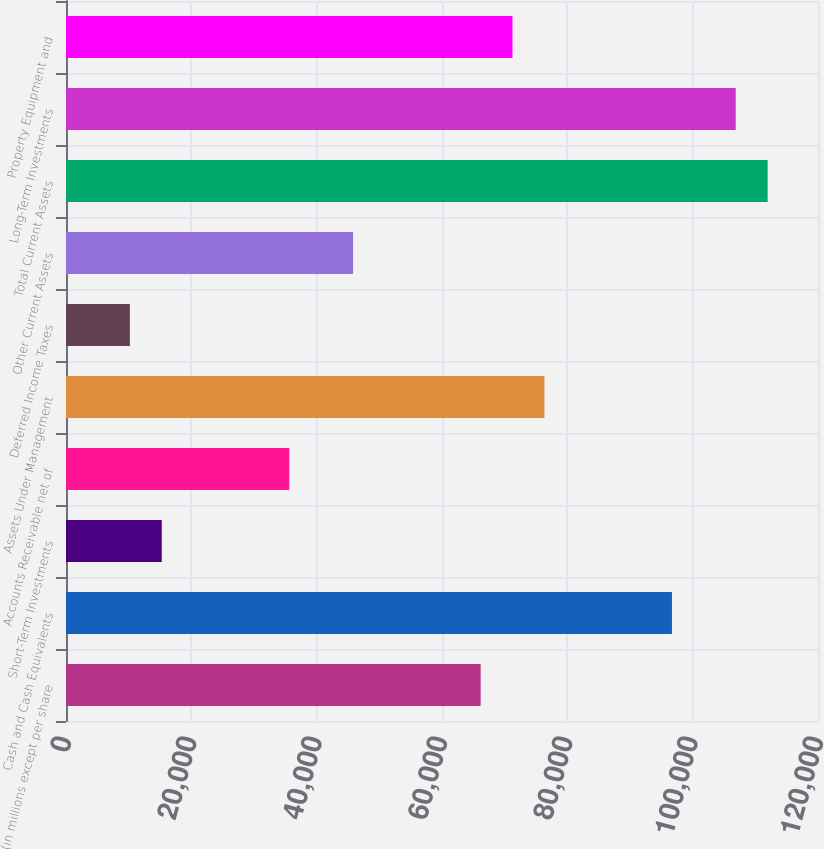<chart> <loc_0><loc_0><loc_500><loc_500><bar_chart><fcel>(in millions except per share<fcel>Cash and Cash Equivalents<fcel>Short-Term Investments<fcel>Accounts Receivable net of<fcel>Assets Under Management<fcel>Deferred Income Taxes<fcel>Other Current Assets<fcel>Total Current Assets<fcel>Long-Term Investments<fcel>Property Equipment and<nl><fcel>66164.8<fcel>96696.4<fcel>15278.8<fcel>35633.2<fcel>76342<fcel>10190.2<fcel>45810.4<fcel>111962<fcel>106874<fcel>71253.4<nl></chart> 